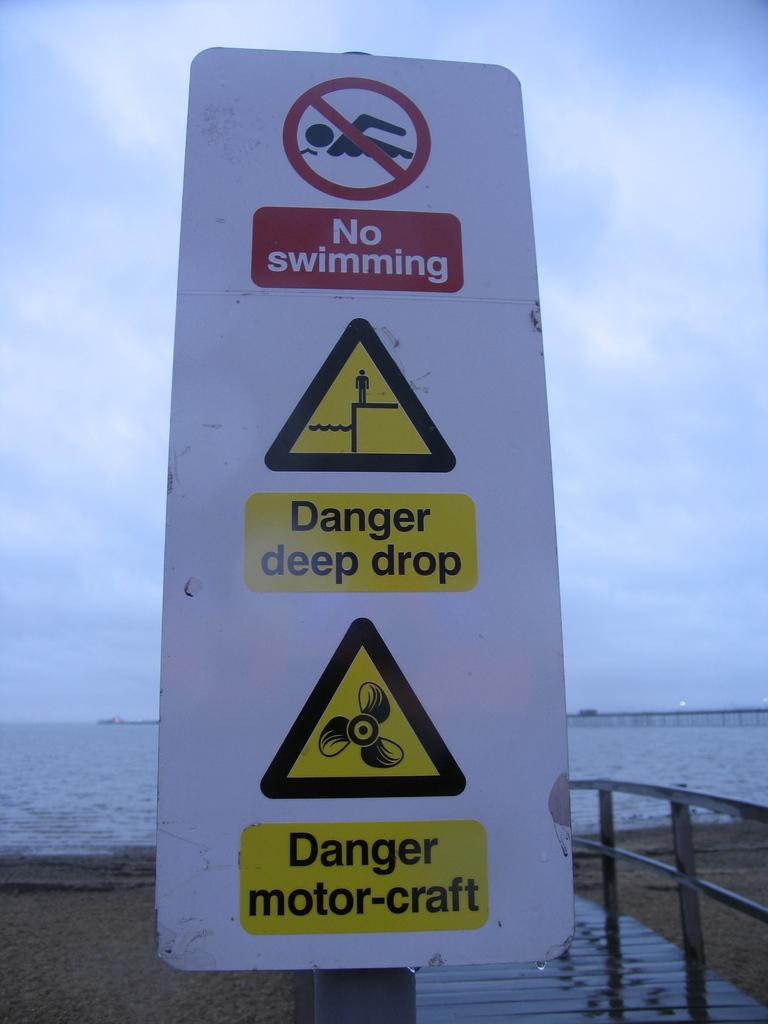<image>
Provide a brief description of the given image. A white sign designates no swimming, warns of a deep drop, and prohibits motor-craft. 